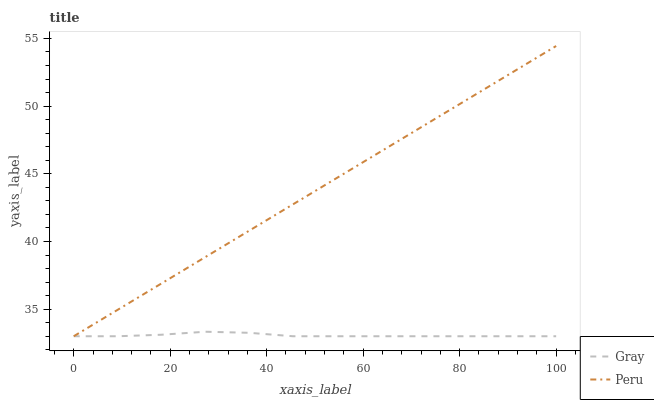Does Gray have the minimum area under the curve?
Answer yes or no. Yes. Does Peru have the maximum area under the curve?
Answer yes or no. Yes. Does Peru have the minimum area under the curve?
Answer yes or no. No. Is Peru the smoothest?
Answer yes or no. Yes. Is Gray the roughest?
Answer yes or no. Yes. Is Peru the roughest?
Answer yes or no. No. Does Gray have the lowest value?
Answer yes or no. Yes. Does Peru have the highest value?
Answer yes or no. Yes. Does Gray intersect Peru?
Answer yes or no. Yes. Is Gray less than Peru?
Answer yes or no. No. Is Gray greater than Peru?
Answer yes or no. No. 